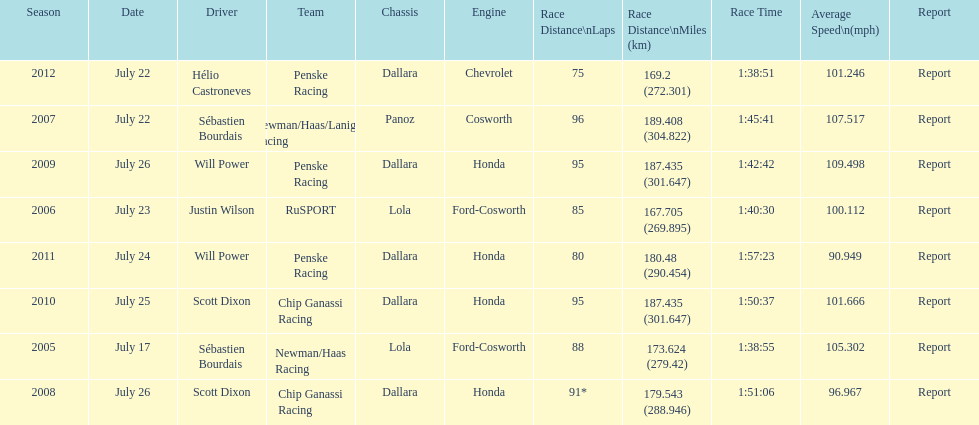What is the total number dallara chassis listed in the table? 5. 